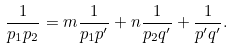<formula> <loc_0><loc_0><loc_500><loc_500>\frac { 1 } { p _ { 1 } p _ { 2 } } = m \frac { 1 } { p _ { 1 } p ^ { \prime } } + n \frac { 1 } { p _ { 2 } q ^ { \prime } } + \frac { 1 } { p ^ { \prime } q ^ { \prime } } .</formula> 